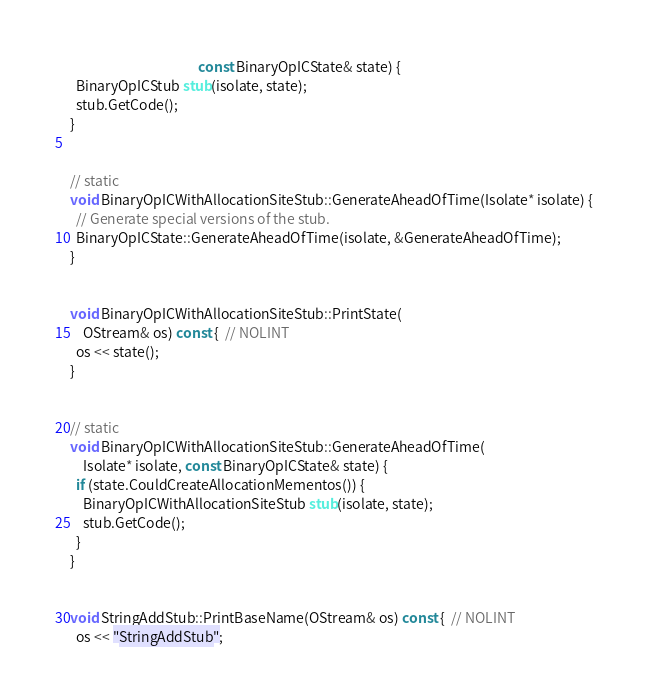<code> <loc_0><loc_0><loc_500><loc_500><_C++_>                                         const BinaryOpICState& state) {
  BinaryOpICStub stub(isolate, state);
  stub.GetCode();
}


// static
void BinaryOpICWithAllocationSiteStub::GenerateAheadOfTime(Isolate* isolate) {
  // Generate special versions of the stub.
  BinaryOpICState::GenerateAheadOfTime(isolate, &GenerateAheadOfTime);
}


void BinaryOpICWithAllocationSiteStub::PrintState(
    OStream& os) const {  // NOLINT
  os << state();
}


// static
void BinaryOpICWithAllocationSiteStub::GenerateAheadOfTime(
    Isolate* isolate, const BinaryOpICState& state) {
  if (state.CouldCreateAllocationMementos()) {
    BinaryOpICWithAllocationSiteStub stub(isolate, state);
    stub.GetCode();
  }
}


void StringAddStub::PrintBaseName(OStream& os) const {  // NOLINT
  os << "StringAddStub";</code> 